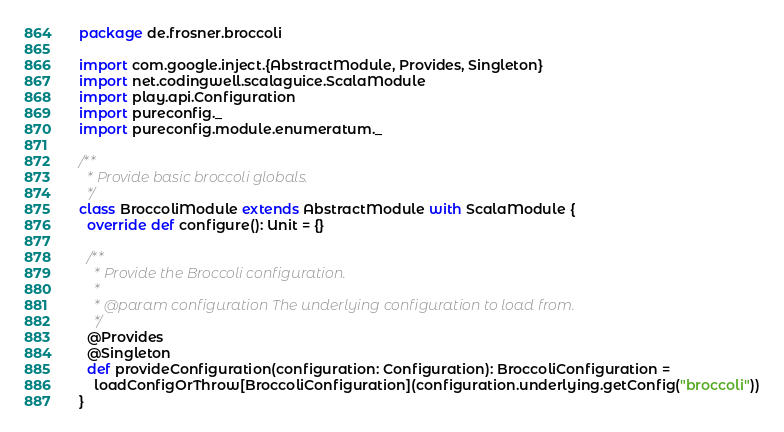Convert code to text. <code><loc_0><loc_0><loc_500><loc_500><_Scala_>package de.frosner.broccoli

import com.google.inject.{AbstractModule, Provides, Singleton}
import net.codingwell.scalaguice.ScalaModule
import play.api.Configuration
import pureconfig._
import pureconfig.module.enumeratum._

/**
  * Provide basic broccoli globals.
  */
class BroccoliModule extends AbstractModule with ScalaModule {
  override def configure(): Unit = {}

  /**
    * Provide the Broccoli configuration.
    *
    * @param configuration The underlying configuration to load from.
    */
  @Provides
  @Singleton
  def provideConfiguration(configuration: Configuration): BroccoliConfiguration =
    loadConfigOrThrow[BroccoliConfiguration](configuration.underlying.getConfig("broccoli"))
}
</code> 